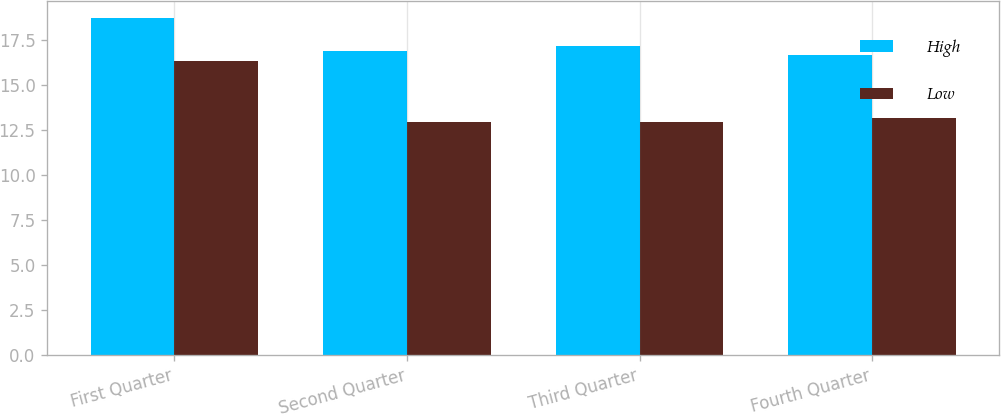<chart> <loc_0><loc_0><loc_500><loc_500><stacked_bar_chart><ecel><fcel>First Quarter<fcel>Second Quarter<fcel>Third Quarter<fcel>Fourth Quarter<nl><fcel>High<fcel>18.7<fcel>16.89<fcel>17.16<fcel>16.62<nl><fcel>Low<fcel>16.29<fcel>12.94<fcel>12.92<fcel>13.13<nl></chart> 